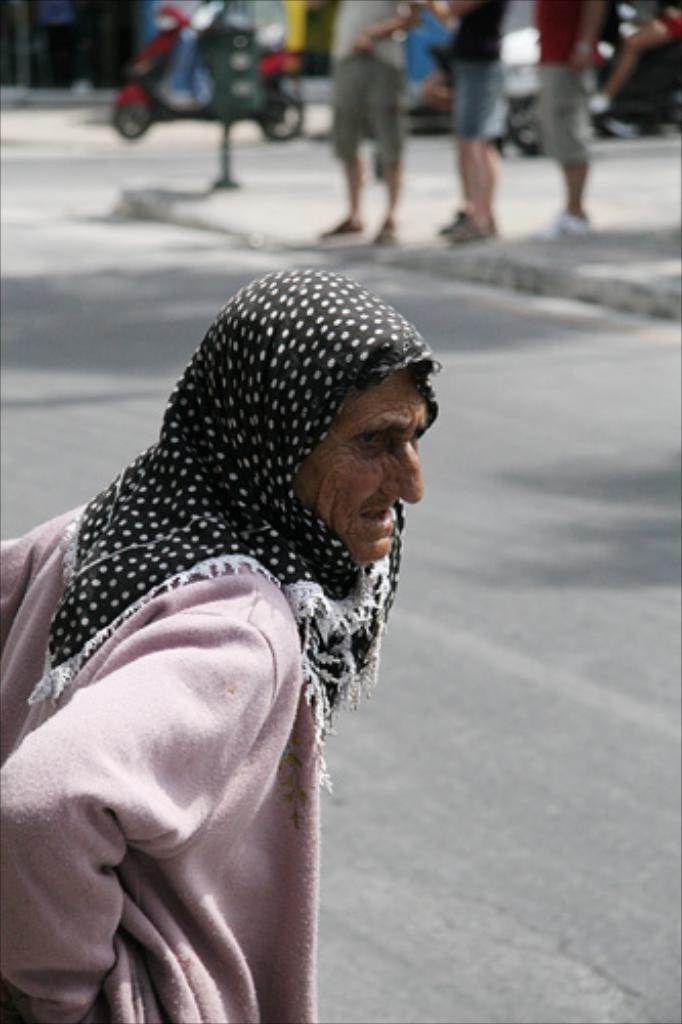What is the person on the left side of the image wearing? The person is wearing a jacket and a scarf. Can you describe the people at the top of the image? There are people visible at the top of the image. What else can be seen in the image besides people? There are vehicles, a pole, and a road in the image. Can you hear the grandmother sneezing in the image? There is no mention of a grandmother or sneezing in the image, so it cannot be heard. Is there a snake visible in the image? There is no snake present in the image. 